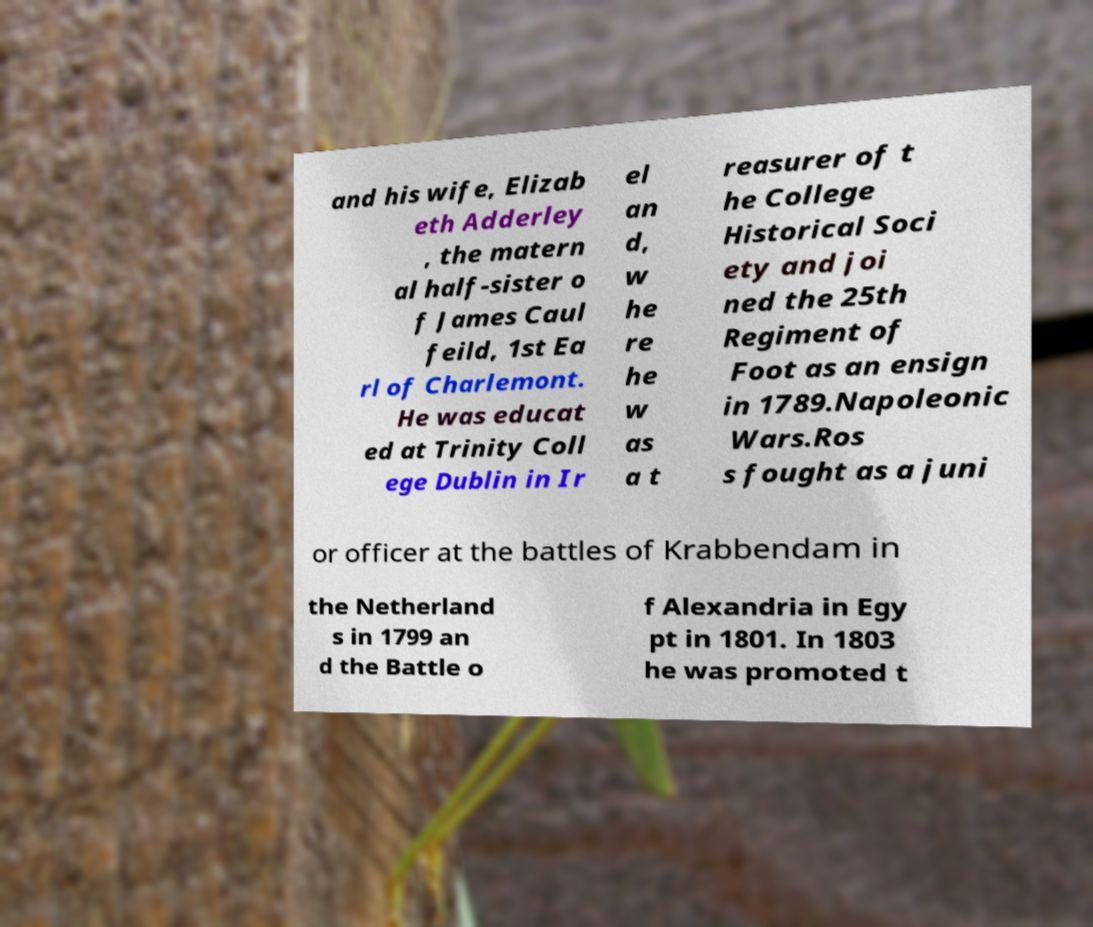Can you accurately transcribe the text from the provided image for me? and his wife, Elizab eth Adderley , the matern al half-sister o f James Caul feild, 1st Ea rl of Charlemont. He was educat ed at Trinity Coll ege Dublin in Ir el an d, w he re he w as a t reasurer of t he College Historical Soci ety and joi ned the 25th Regiment of Foot as an ensign in 1789.Napoleonic Wars.Ros s fought as a juni or officer at the battles of Krabbendam in the Netherland s in 1799 an d the Battle o f Alexandria in Egy pt in 1801. In 1803 he was promoted t 